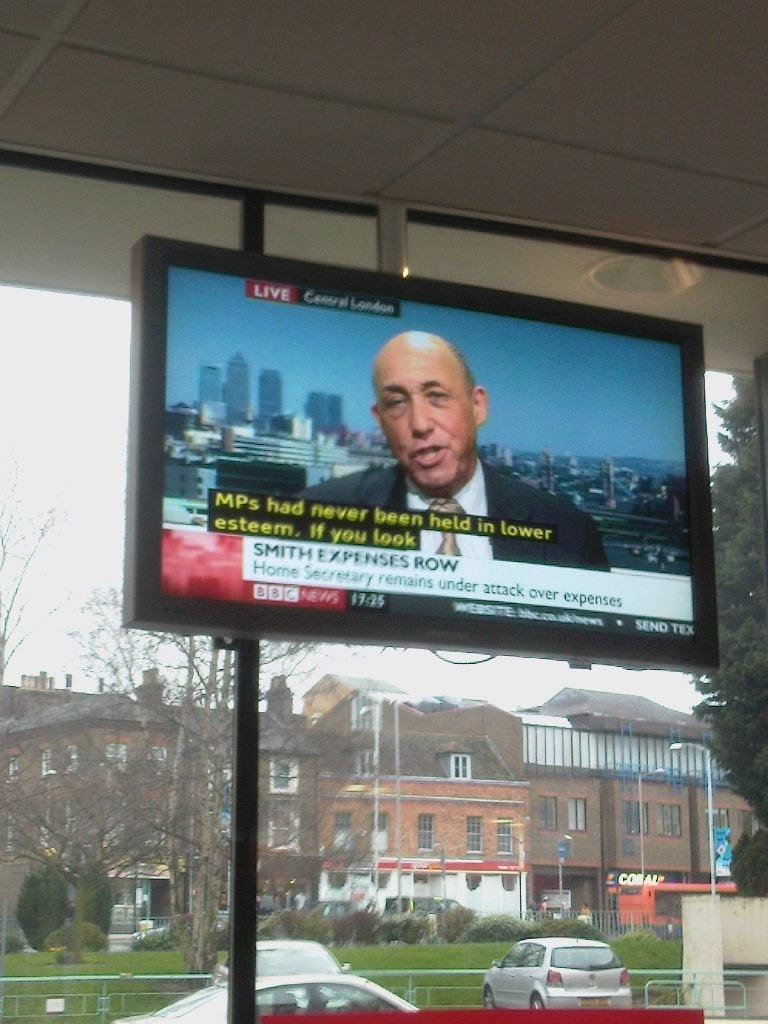Provide a one-sentence caption for the provided image. Live Central London broadcasting new about the Home Secretary being under attack for his expenses. 